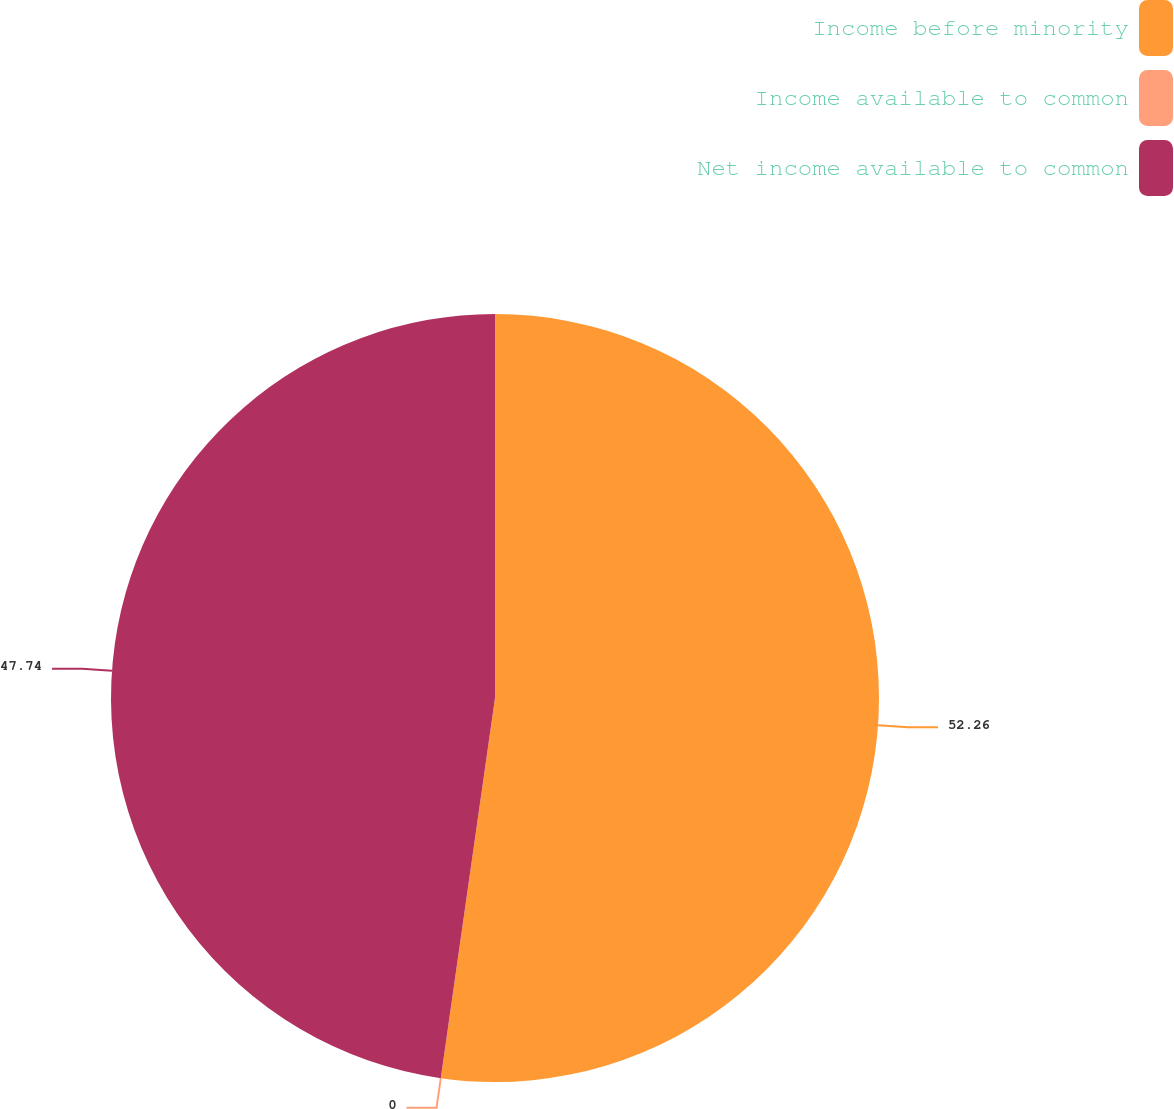Convert chart. <chart><loc_0><loc_0><loc_500><loc_500><pie_chart><fcel>Income before minority<fcel>Income available to common<fcel>Net income available to common<nl><fcel>52.25%<fcel>0.0%<fcel>47.74%<nl></chart> 